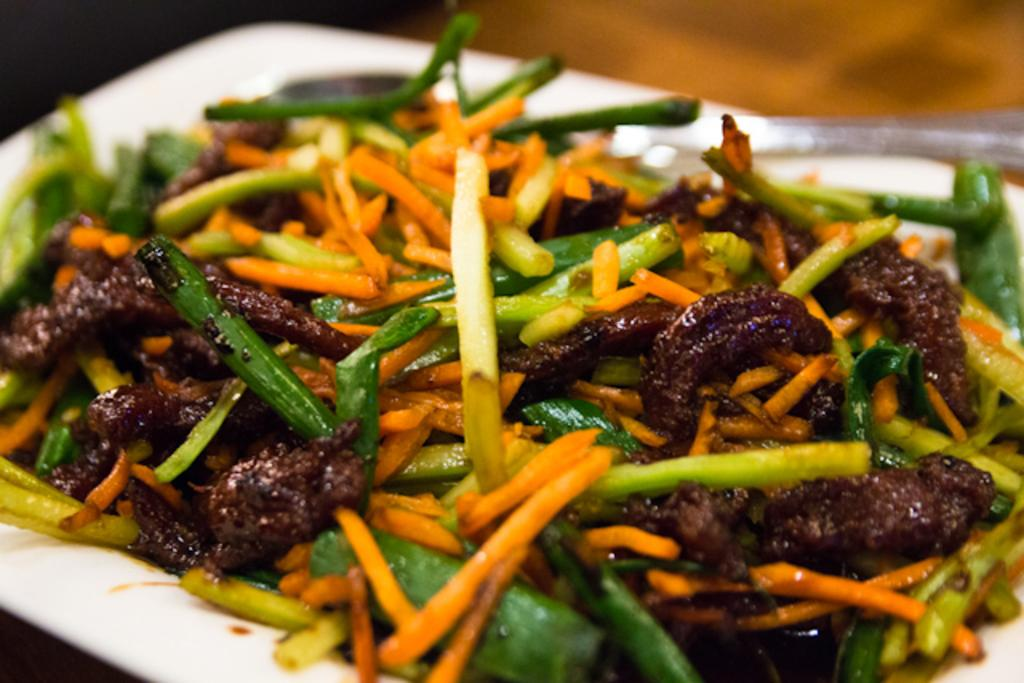What is present in the image can be used for serving food? There is a plate in the image that can be used for serving food. What is on the plate in the image? There are food items placed on the plate in the image. How many friends are visible in the image? There are no friends present in the image; it only shows a plate with food items on it. What type of nail is being used to hold the plate in the image? There is no nail present in the image; the plate is resting on a surface. 